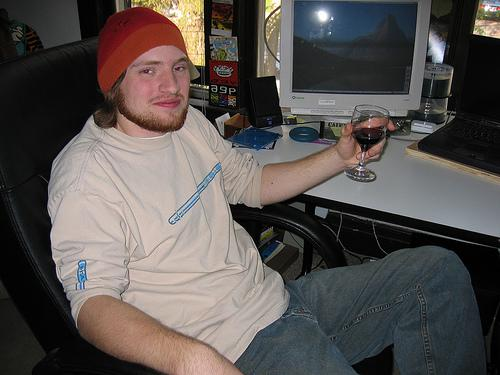Question: where is the man sitting?
Choices:
A. At his desk.
B. In an airport.
C. In a car.
D. On the river bank.
Answer with the letter. Answer: A Question: what is on the desk?
Choices:
A. A coffee cup.
B. A laptop.
C. A monitor.
D. An iPad.
Answer with the letter. Answer: C Question: what is in the glass?
Choices:
A. Water.
B. Soda.
C. Beer.
D. Wine.
Answer with the letter. Answer: D Question: how many people are at the desk?
Choices:
A. Two.
B. One.
C. Three.
D. None.
Answer with the letter. Answer: B Question: what is on the man's head?
Choices:
A. Scarf.
B. A hat.
C. Helmet.
D. Glasses.
Answer with the letter. Answer: B 